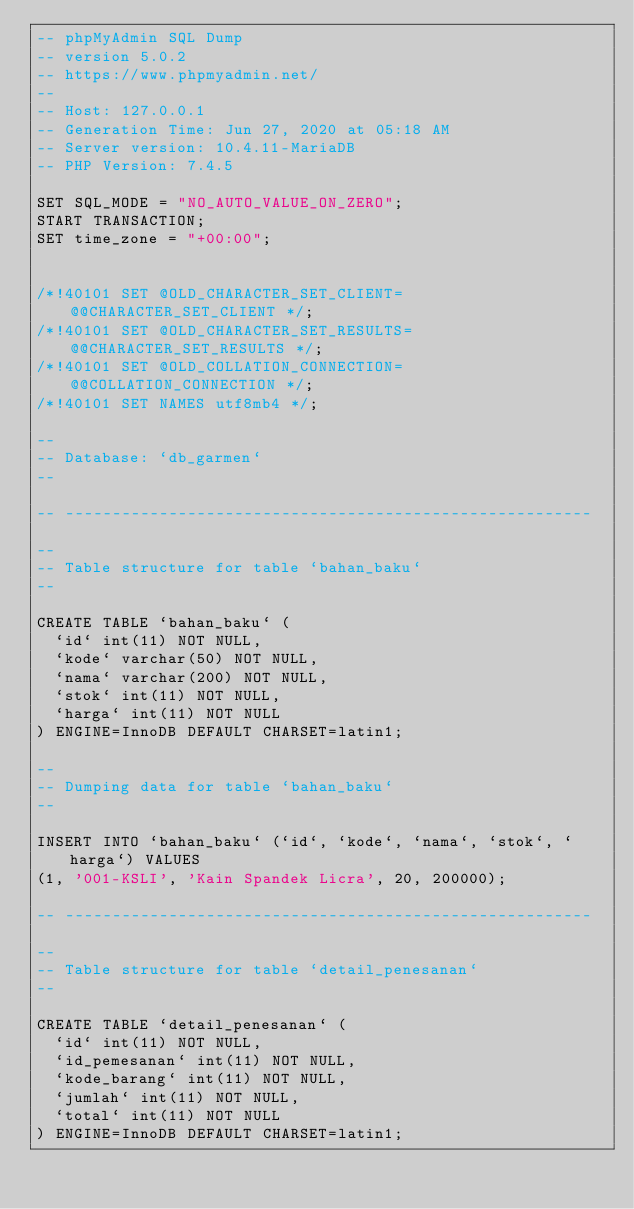<code> <loc_0><loc_0><loc_500><loc_500><_SQL_>-- phpMyAdmin SQL Dump
-- version 5.0.2
-- https://www.phpmyadmin.net/
--
-- Host: 127.0.0.1
-- Generation Time: Jun 27, 2020 at 05:18 AM
-- Server version: 10.4.11-MariaDB
-- PHP Version: 7.4.5

SET SQL_MODE = "NO_AUTO_VALUE_ON_ZERO";
START TRANSACTION;
SET time_zone = "+00:00";


/*!40101 SET @OLD_CHARACTER_SET_CLIENT=@@CHARACTER_SET_CLIENT */;
/*!40101 SET @OLD_CHARACTER_SET_RESULTS=@@CHARACTER_SET_RESULTS */;
/*!40101 SET @OLD_COLLATION_CONNECTION=@@COLLATION_CONNECTION */;
/*!40101 SET NAMES utf8mb4 */;

--
-- Database: `db_garmen`
--

-- --------------------------------------------------------

--
-- Table structure for table `bahan_baku`
--

CREATE TABLE `bahan_baku` (
  `id` int(11) NOT NULL,
  `kode` varchar(50) NOT NULL,
  `nama` varchar(200) NOT NULL,
  `stok` int(11) NOT NULL,
  `harga` int(11) NOT NULL
) ENGINE=InnoDB DEFAULT CHARSET=latin1;

--
-- Dumping data for table `bahan_baku`
--

INSERT INTO `bahan_baku` (`id`, `kode`, `nama`, `stok`, `harga`) VALUES
(1, '001-KSLI', 'Kain Spandek Licra', 20, 200000);

-- --------------------------------------------------------

--
-- Table structure for table `detail_penesanan`
--

CREATE TABLE `detail_penesanan` (
  `id` int(11) NOT NULL,
  `id_pemesanan` int(11) NOT NULL,
  `kode_barang` int(11) NOT NULL,
  `jumlah` int(11) NOT NULL,
  `total` int(11) NOT NULL
) ENGINE=InnoDB DEFAULT CHARSET=latin1;
</code> 